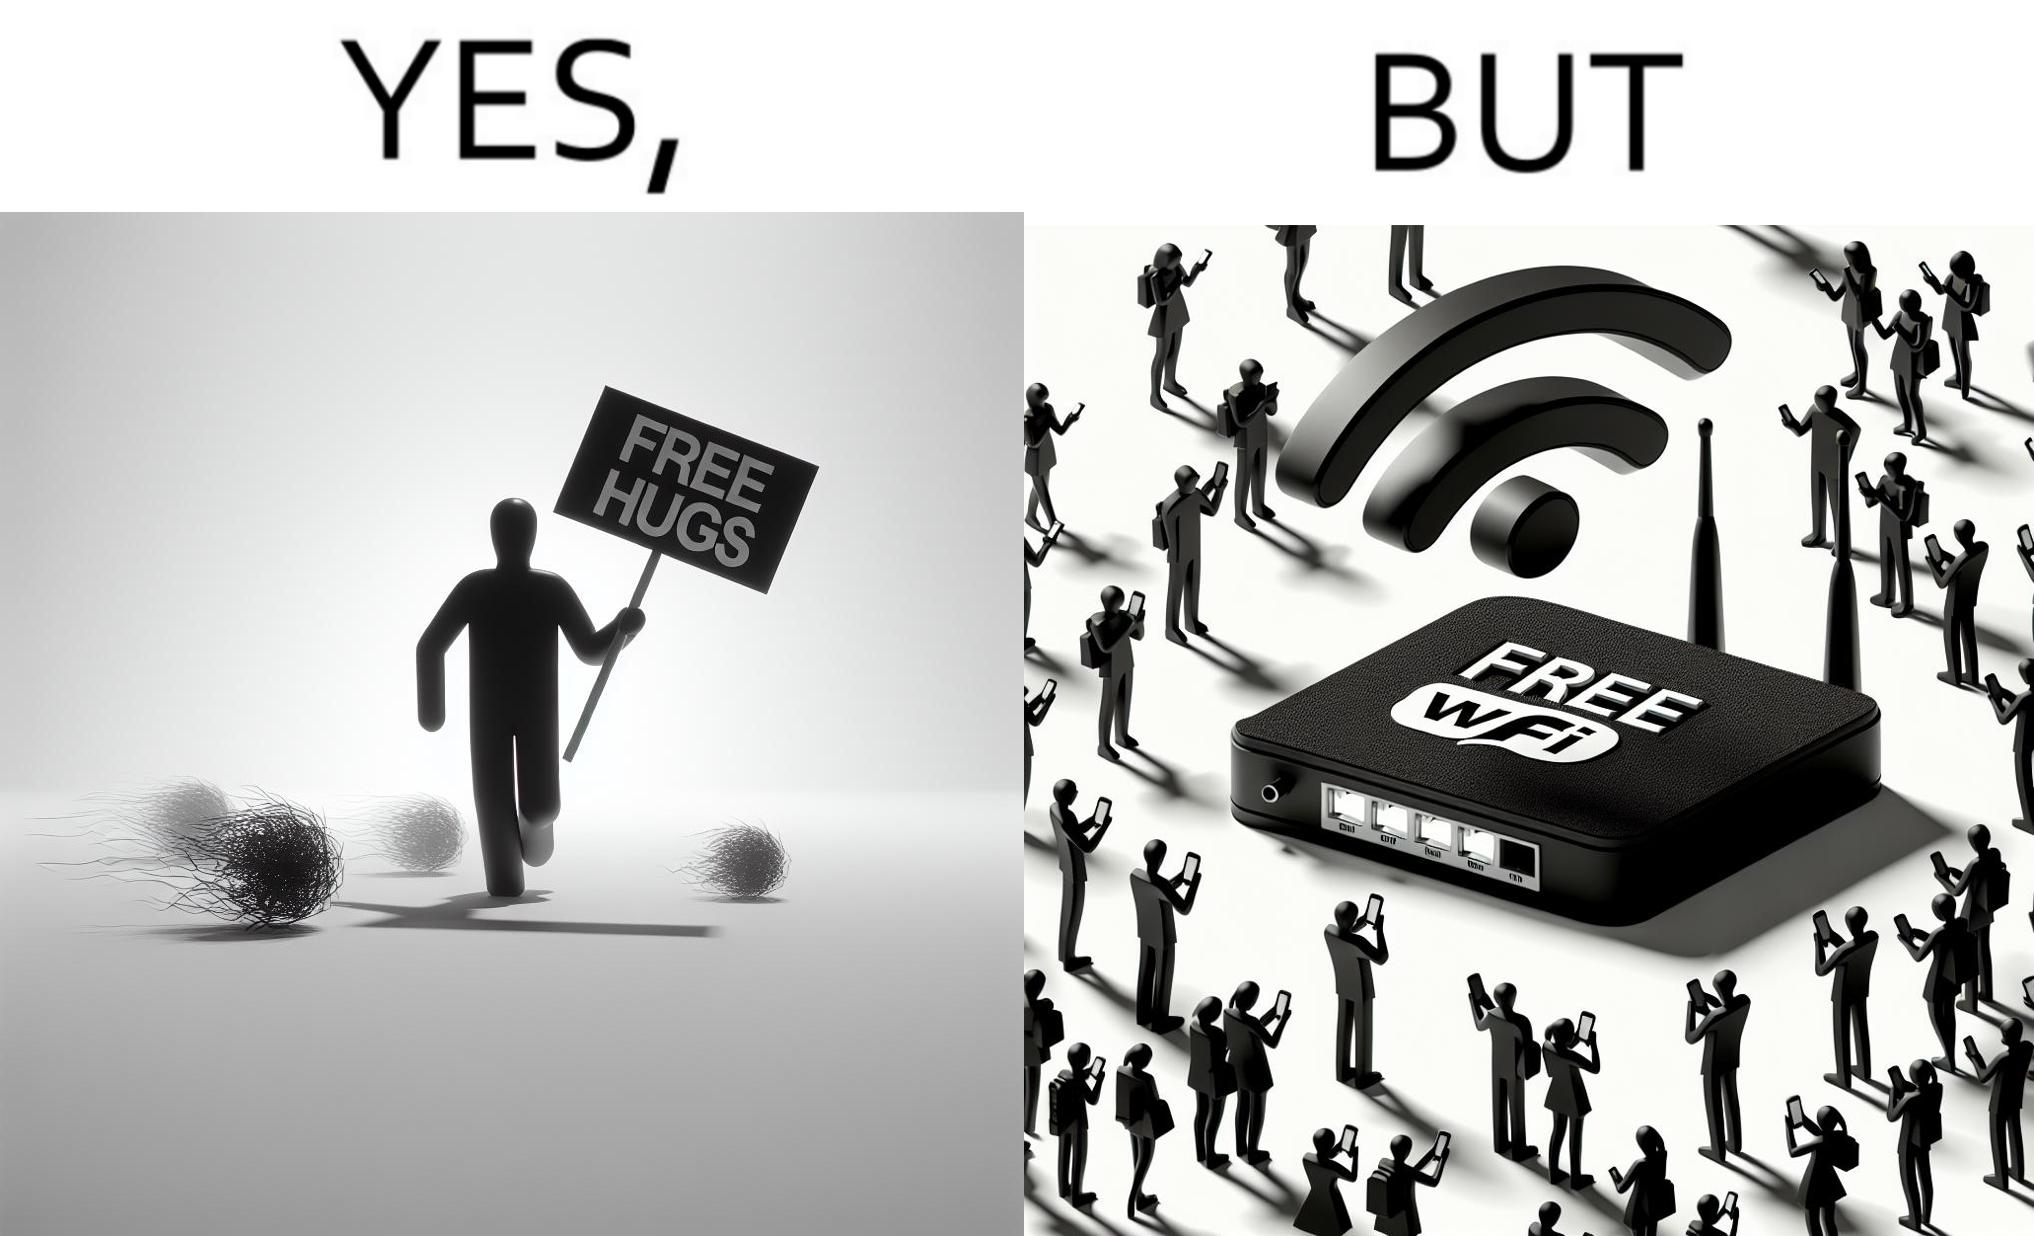Describe what you see in the left and right parts of this image. In the left part of the image: a person standing alone holding a sign "Free Hugs". The tumbleweeds blowing in the wind further stress on the loneliness. In the right part of the image: A Wi-fi Router with the label "Free Wifi" in front of it, surrounded by people trying to connect to it on their mobile devices. 